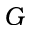Convert formula to latex. <formula><loc_0><loc_0><loc_500><loc_500>G</formula> 